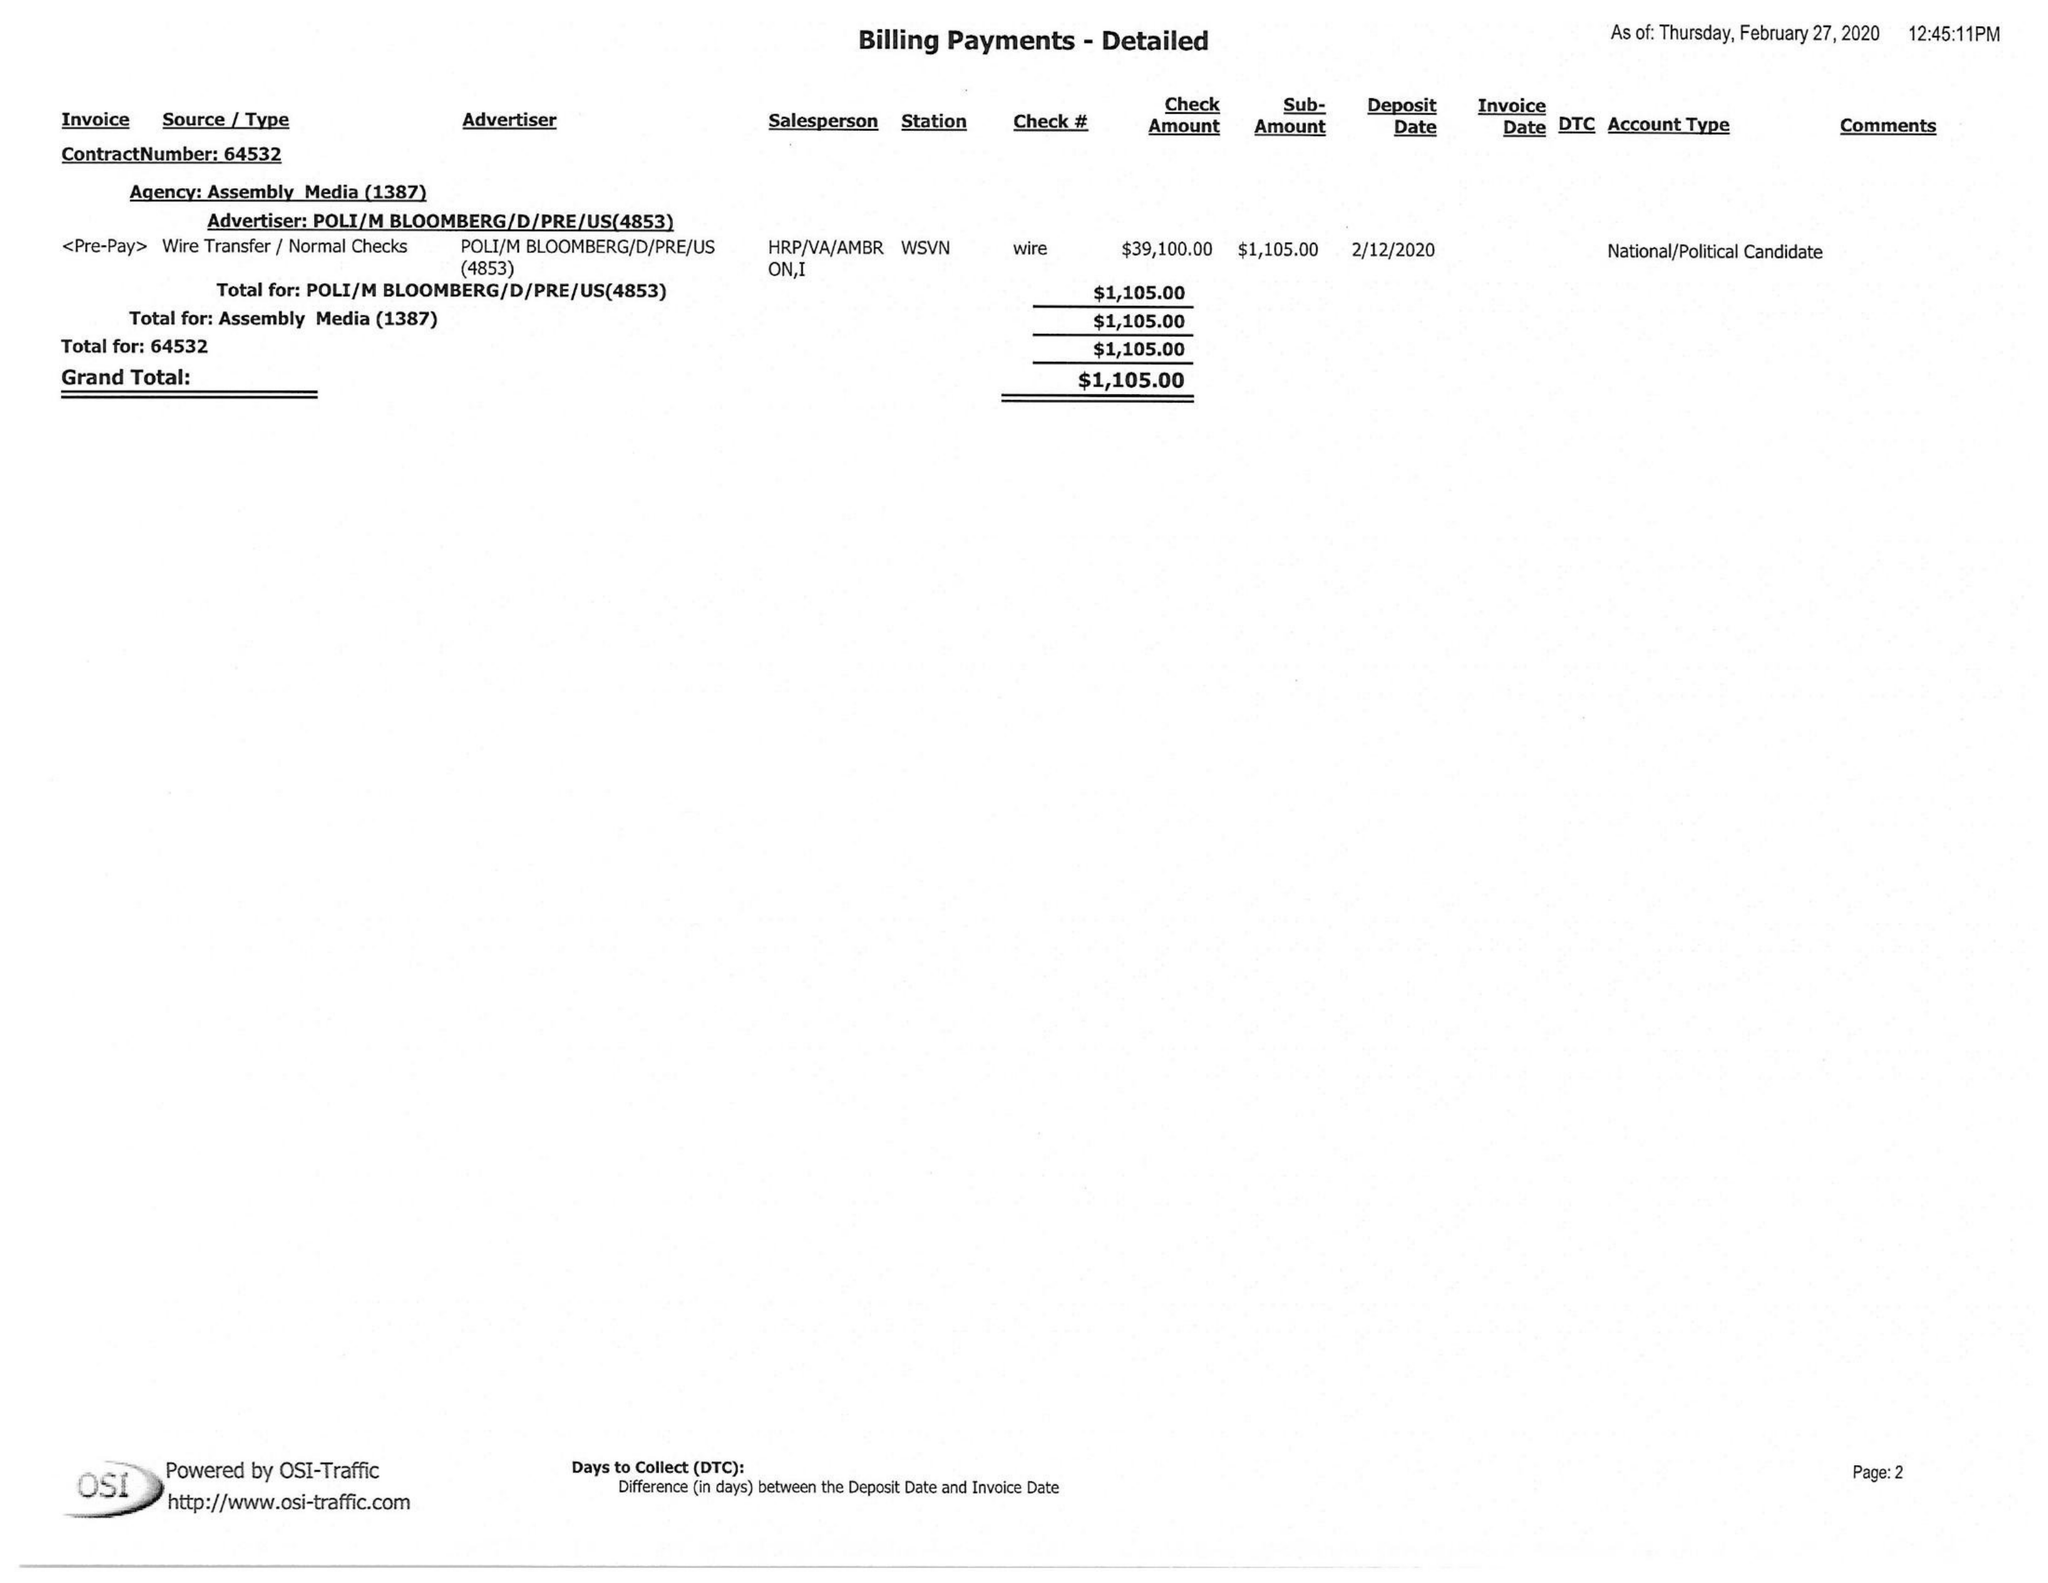What is the value for the flight_from?
Answer the question using a single word or phrase. None 